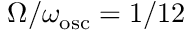<formula> <loc_0><loc_0><loc_500><loc_500>\Omega / \omega _ { o s c } = 1 / 1 2</formula> 